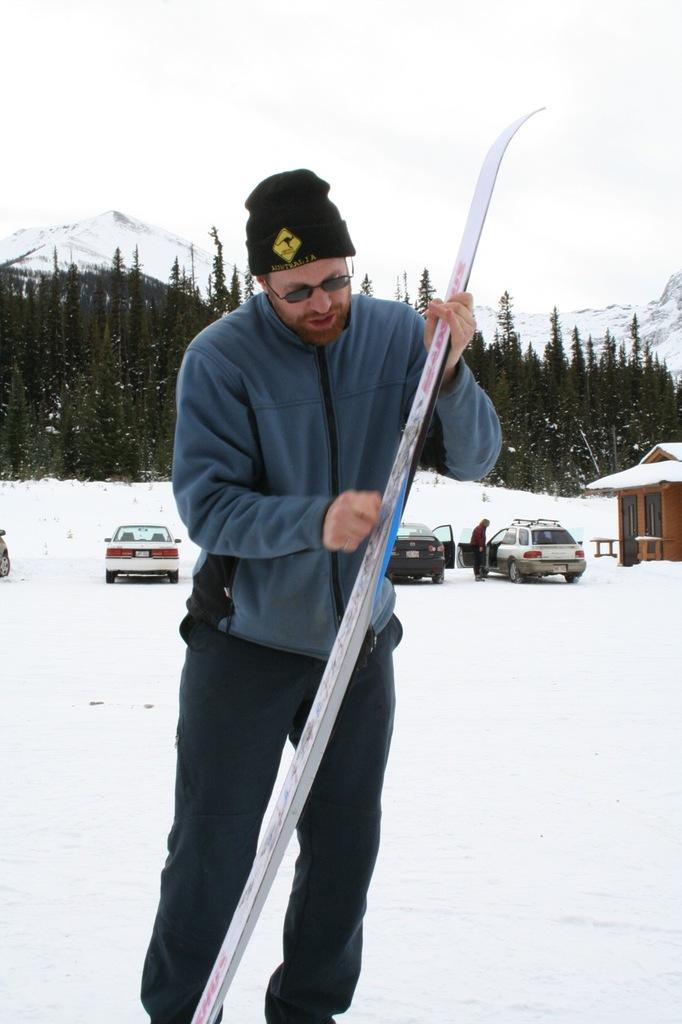What is the person holding in the image? The person is holding an object in the image. What is the position of the person in the image? The person is standing in the image. What else can be seen in the image besides the person? There are vehicles, trees, mountains covered with snow, and the sky visible in the image. How many people are present in the image? There is at least one person in the image. What action does the person's brother take to show respect in the image? There is no mention of a brother or any action to show respect in the image. 